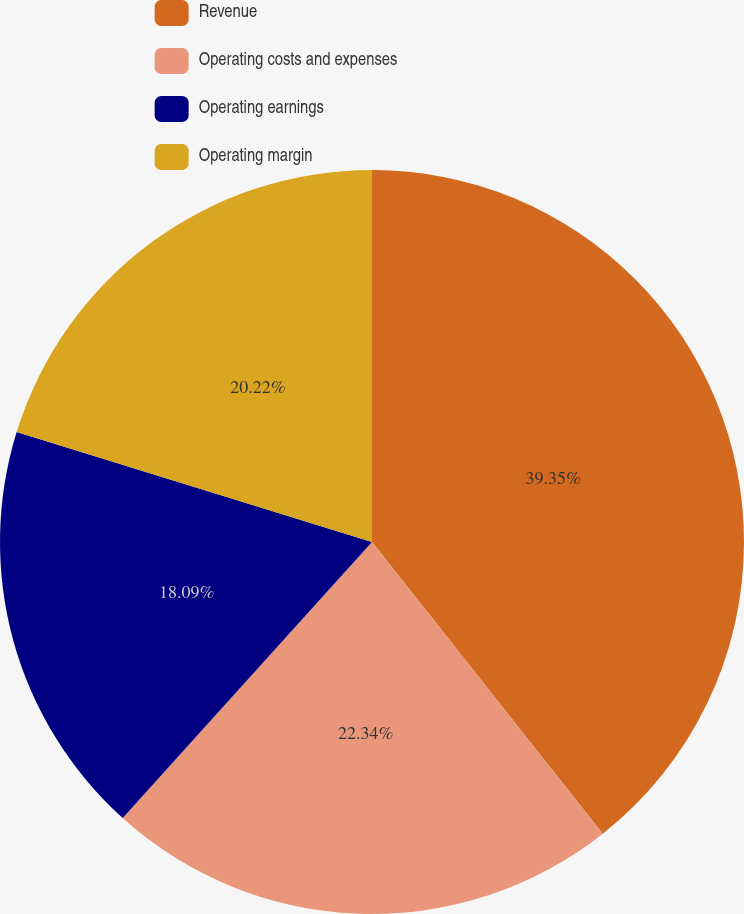<chart> <loc_0><loc_0><loc_500><loc_500><pie_chart><fcel>Revenue<fcel>Operating costs and expenses<fcel>Operating earnings<fcel>Operating margin<nl><fcel>39.35%<fcel>22.34%<fcel>18.09%<fcel>20.22%<nl></chart> 